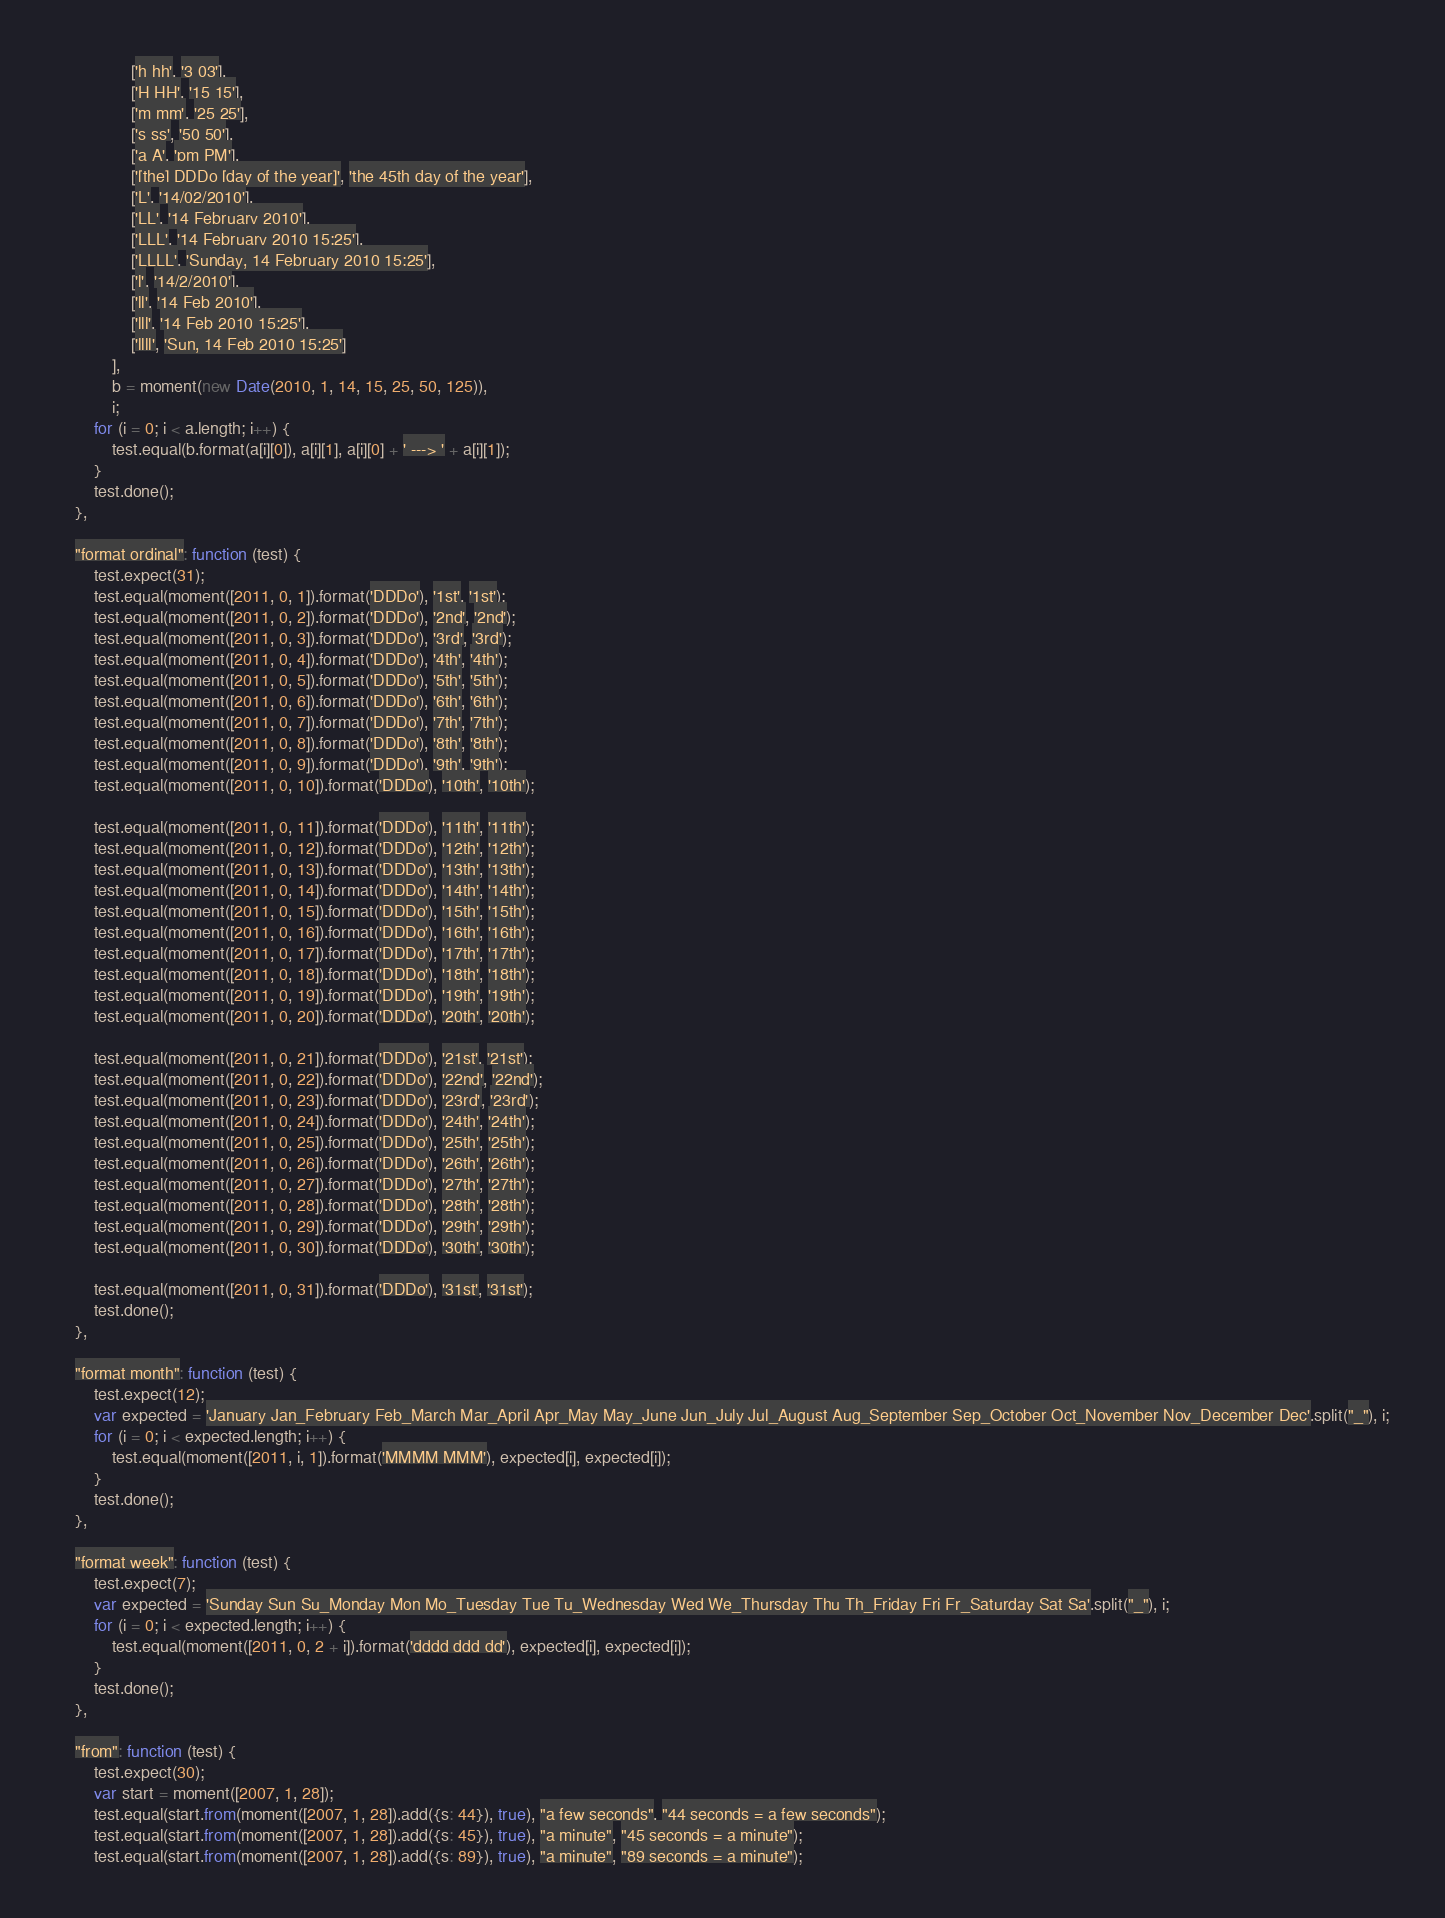Convert code to text. <code><loc_0><loc_0><loc_500><loc_500><_JavaScript_>                ['h hh', '3 03'],
                ['H HH', '15 15'],
                ['m mm', '25 25'],
                ['s ss', '50 50'],
                ['a A', 'pm PM'],
                ['[the] DDDo [day of the year]', 'the 45th day of the year'],
                ['L', '14/02/2010'],
                ['LL', '14 February 2010'],
                ['LLL', '14 February 2010 15:25'],
                ['LLLL', 'Sunday, 14 February 2010 15:25'],
                ['l', '14/2/2010'],
                ['ll', '14 Feb 2010'],
                ['lll', '14 Feb 2010 15:25'],
                ['llll', 'Sun, 14 Feb 2010 15:25']
            ],
            b = moment(new Date(2010, 1, 14, 15, 25, 50, 125)),
            i;
        for (i = 0; i < a.length; i++) {
            test.equal(b.format(a[i][0]), a[i][1], a[i][0] + ' ---> ' + a[i][1]);
        }
        test.done();
    },

    "format ordinal": function (test) {
        test.expect(31);
        test.equal(moment([2011, 0, 1]).format('DDDo'), '1st', '1st');
        test.equal(moment([2011, 0, 2]).format('DDDo'), '2nd', '2nd');
        test.equal(moment([2011, 0, 3]).format('DDDo'), '3rd', '3rd');
        test.equal(moment([2011, 0, 4]).format('DDDo'), '4th', '4th');
        test.equal(moment([2011, 0, 5]).format('DDDo'), '5th', '5th');
        test.equal(moment([2011, 0, 6]).format('DDDo'), '6th', '6th');
        test.equal(moment([2011, 0, 7]).format('DDDo'), '7th', '7th');
        test.equal(moment([2011, 0, 8]).format('DDDo'), '8th', '8th');
        test.equal(moment([2011, 0, 9]).format('DDDo'), '9th', '9th');
        test.equal(moment([2011, 0, 10]).format('DDDo'), '10th', '10th');

        test.equal(moment([2011, 0, 11]).format('DDDo'), '11th', '11th');
        test.equal(moment([2011, 0, 12]).format('DDDo'), '12th', '12th');
        test.equal(moment([2011, 0, 13]).format('DDDo'), '13th', '13th');
        test.equal(moment([2011, 0, 14]).format('DDDo'), '14th', '14th');
        test.equal(moment([2011, 0, 15]).format('DDDo'), '15th', '15th');
        test.equal(moment([2011, 0, 16]).format('DDDo'), '16th', '16th');
        test.equal(moment([2011, 0, 17]).format('DDDo'), '17th', '17th');
        test.equal(moment([2011, 0, 18]).format('DDDo'), '18th', '18th');
        test.equal(moment([2011, 0, 19]).format('DDDo'), '19th', '19th');
        test.equal(moment([2011, 0, 20]).format('DDDo'), '20th', '20th');

        test.equal(moment([2011, 0, 21]).format('DDDo'), '21st', '21st');
        test.equal(moment([2011, 0, 22]).format('DDDo'), '22nd', '22nd');
        test.equal(moment([2011, 0, 23]).format('DDDo'), '23rd', '23rd');
        test.equal(moment([2011, 0, 24]).format('DDDo'), '24th', '24th');
        test.equal(moment([2011, 0, 25]).format('DDDo'), '25th', '25th');
        test.equal(moment([2011, 0, 26]).format('DDDo'), '26th', '26th');
        test.equal(moment([2011, 0, 27]).format('DDDo'), '27th', '27th');
        test.equal(moment([2011, 0, 28]).format('DDDo'), '28th', '28th');
        test.equal(moment([2011, 0, 29]).format('DDDo'), '29th', '29th');
        test.equal(moment([2011, 0, 30]).format('DDDo'), '30th', '30th');

        test.equal(moment([2011, 0, 31]).format('DDDo'), '31st', '31st');
        test.done();
    },

    "format month": function (test) {
        test.expect(12);
        var expected = 'January Jan_February Feb_March Mar_April Apr_May May_June Jun_July Jul_August Aug_September Sep_October Oct_November Nov_December Dec'.split("_"), i;
        for (i = 0; i < expected.length; i++) {
            test.equal(moment([2011, i, 1]).format('MMMM MMM'), expected[i], expected[i]);
        }
        test.done();
    },

    "format week": function (test) {
        test.expect(7);
        var expected = 'Sunday Sun Su_Monday Mon Mo_Tuesday Tue Tu_Wednesday Wed We_Thursday Thu Th_Friday Fri Fr_Saturday Sat Sa'.split("_"), i;
        for (i = 0; i < expected.length; i++) {
            test.equal(moment([2011, 0, 2 + i]).format('dddd ddd dd'), expected[i], expected[i]);
        }
        test.done();
    },

    "from": function (test) {
        test.expect(30);
        var start = moment([2007, 1, 28]);
        test.equal(start.from(moment([2007, 1, 28]).add({s: 44}), true), "a few seconds", "44 seconds = a few seconds");
        test.equal(start.from(moment([2007, 1, 28]).add({s: 45}), true), "a minute", "45 seconds = a minute");
        test.equal(start.from(moment([2007, 1, 28]).add({s: 89}), true), "a minute", "89 seconds = a minute");</code> 